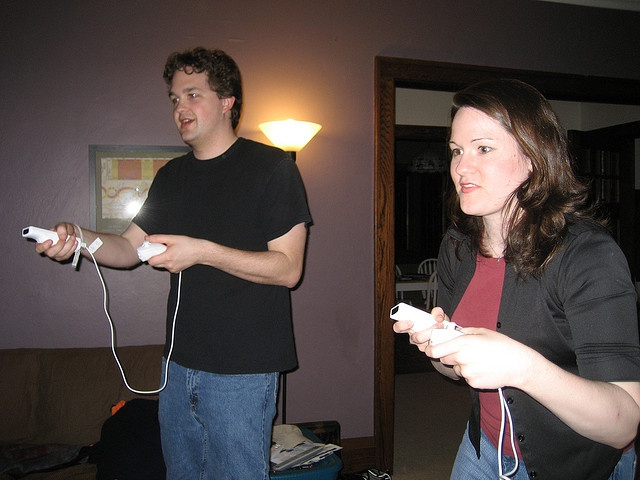Describe the objects in this image and their specific colors. I can see people in black, white, gray, and brown tones, people in black, blue, tan, and gray tones, couch in black, white, and gray tones, remote in black, white, lightpink, and darkgray tones, and remote in black, white, darkgray, and gray tones in this image. 